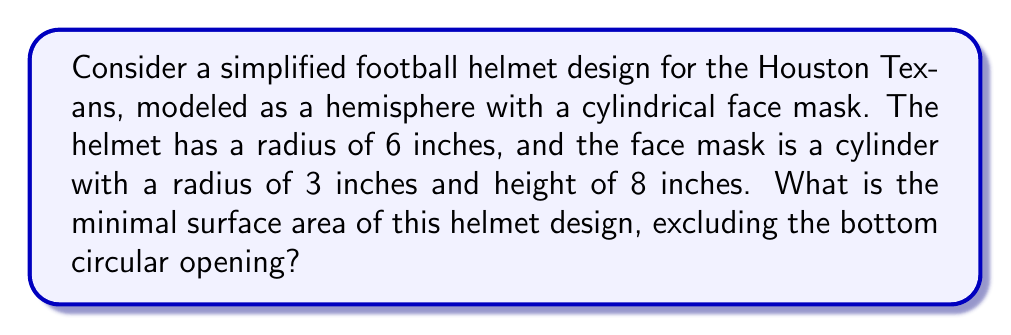Could you help me with this problem? Let's approach this step-by-step:

1) The helmet consists of two parts: the hemispherical shell and the cylindrical face mask.

2) For the hemispherical shell:
   - Surface area of a hemisphere = $2\pi r^2$
   - Radius $r = 6$ inches
   - Surface area of hemisphere = $2\pi (6^2) = 72\pi$ sq inches

3) For the cylindrical face mask:
   - Surface area of a cylinder (excluding bases) = $2\pi rh$
   - Radius $r = 3$ inches, height $h = 8$ inches
   - Surface area of cylinder = $2\pi (3)(8) = 48\pi$ sq inches

4) Total surface area:
   $$ A_{total} = A_{hemisphere} + A_{cylinder} $$
   $$ A_{total} = 72\pi + 48\pi = 120\pi \text{ sq inches} $$

5) Converting to square feet:
   $$ A_{total} = \frac{120\pi}{144} \approx 2.618 \text{ sq feet} $$

This design represents a minimal surface area as it uses simple geometric shapes (hemisphere and cylinder) that inherently minimize surface area for their respective volumes.
Answer: $2.618 \text{ sq feet}$ 